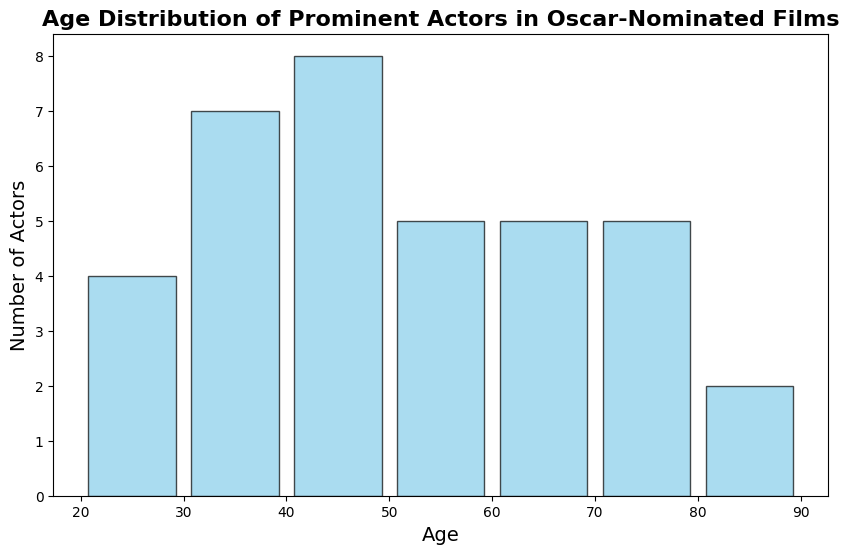How many actors are in the age range of 50-59? The histogram provides the number of actors in each age range. By visually assessing the bar corresponding to the 50-59 age range, count the height of the bar.
Answer: 5 Which age range has the highest number of actors? Identify the tallest bar in the histogram and note the age range it represents.
Answer: 40-49 Are there more actors in the 60-69 age range or the 20-29 age range? Compare the bars corresponding to the age ranges 60-69 and 20-29. The height of each bar represents the number of actors in those age ranges.
Answer: 60-69 What is the average age of the actors in the histogram? Sum all the ages of the actors and then divide by the total number of actors to calculate the average. There are 35 actors, and their ages sum to 1661. The average is 1661/35.
Answer: 47.46 How many age ranges contain exactly one actor? Count the number of bars in the histogram where the height indicates there is only one actor.
Answer: 2 Which age range has the least number of actors, excluding any ranges with zero actors? Find the bar(s) with the shortest height, excluding those with zero height.
Answer: 80-89 Are there any actors aged 90 or above? Check if there are any bars beyond the 80-89 age range with a height greater than zero.
Answer: No What is the range (difference between the maximum and minimum) of the actors' ages? Find the difference between the oldest actor (89) and the youngest actor (24).
Answer: 65 Compare the number of actors in the 30-39 age range to the 40-49 age range. Which has more actors? Visual comparison of the heights of the bars for the 30-39 age range and the 40-49 age range. The 40-49 age range has a taller bar.
Answer: 40-49 How many actors are there in the histogram? Sum the heights of all the bars in the histogram to get the total number of actors.
Answer: 35 